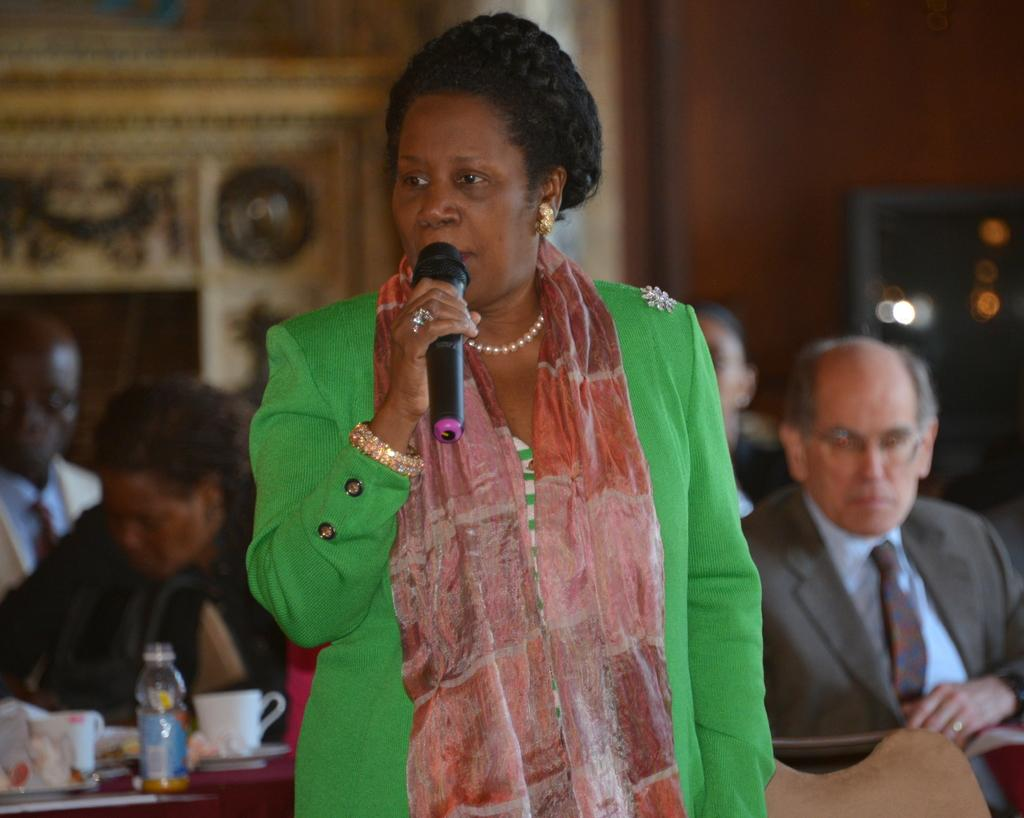Who is the main subject in the image? There is a woman in the image. What is the woman holding in her hand? The woman is holding a mic in her hand. What is the woman's posture in the image? The woman is standing in the image. What can be seen in the background of the image? There are people, a cup, a bottle, a wall, and other objects in the background of the image. Can you see any waves in the image? There are no waves present in the image. What direction is the woman turning in the image? The woman is not turning in the image; she is standing still. 